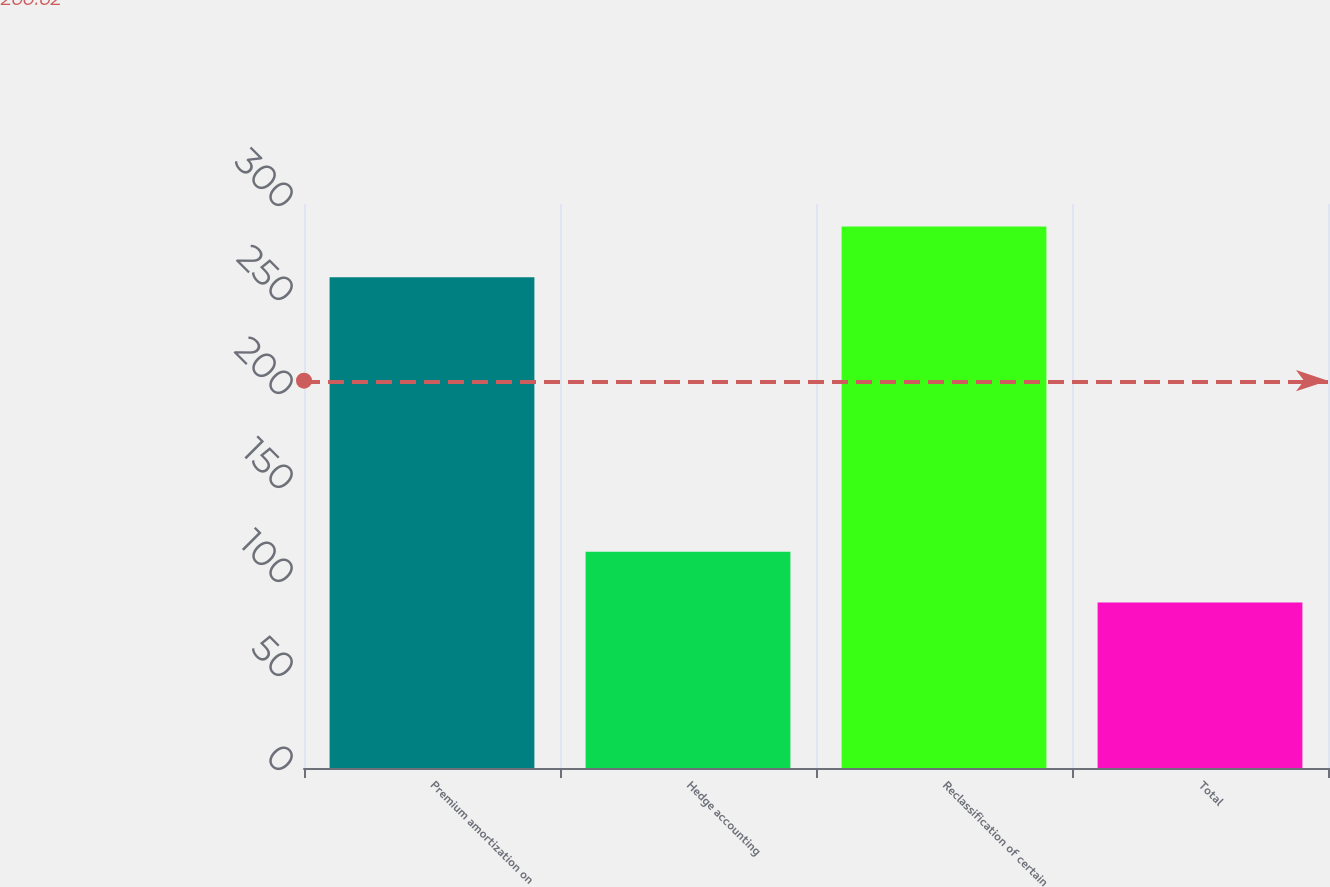<chart> <loc_0><loc_0><loc_500><loc_500><bar_chart><fcel>Premium amortization on<fcel>Hedge accounting<fcel>Reclassification of certain<fcel>Total<nl><fcel>261<fcel>115<fcel>288<fcel>88<nl></chart> 